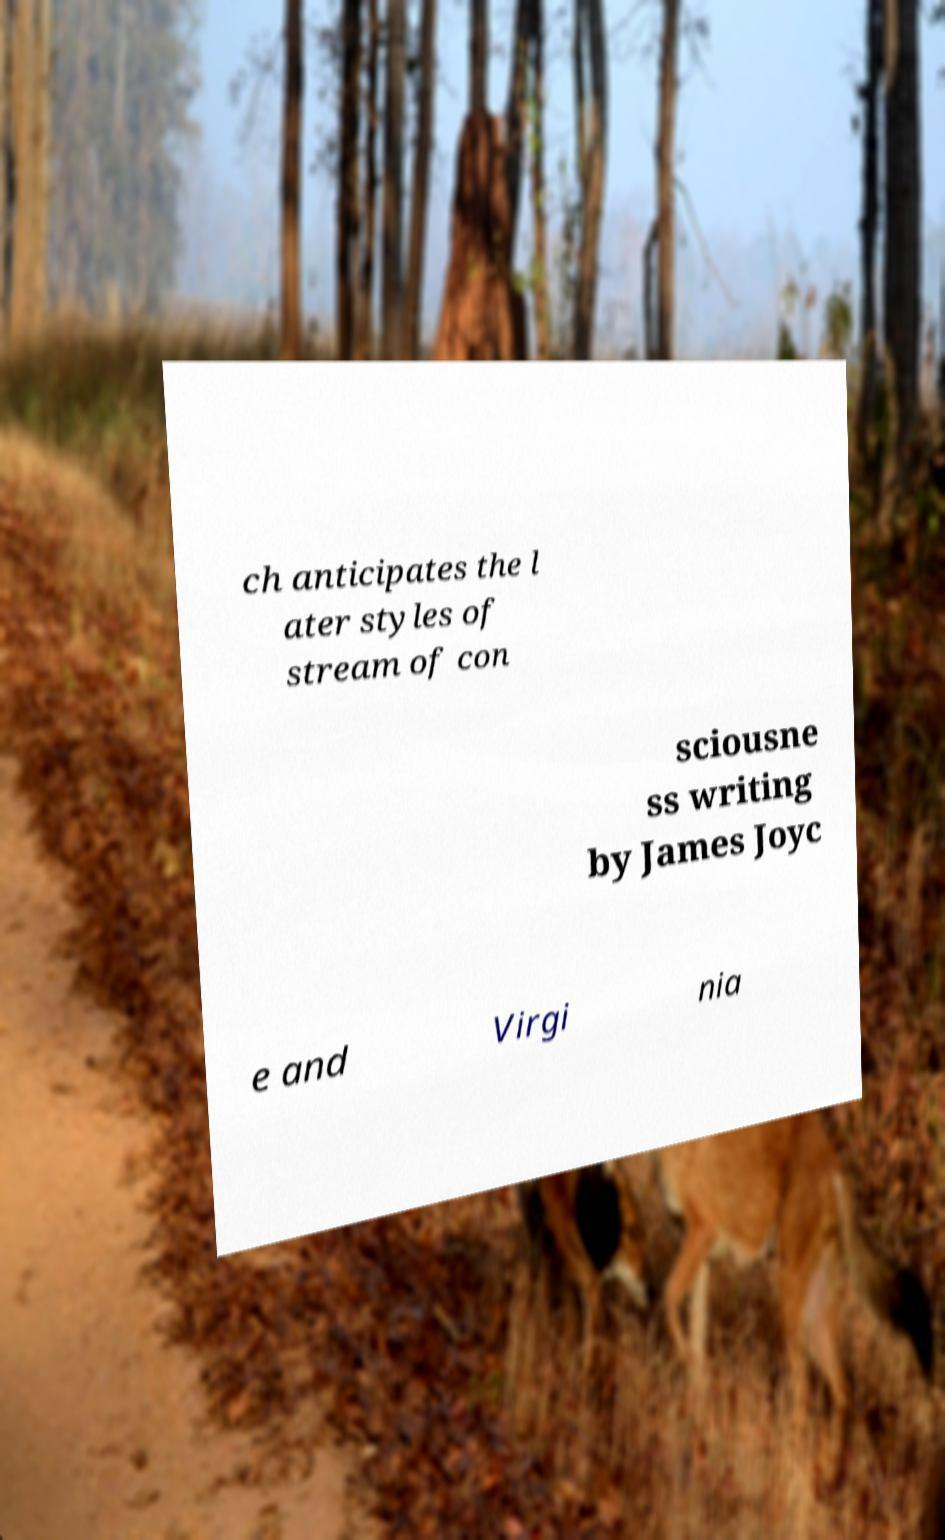Can you accurately transcribe the text from the provided image for me? ch anticipates the l ater styles of stream of con sciousne ss writing by James Joyc e and Virgi nia 